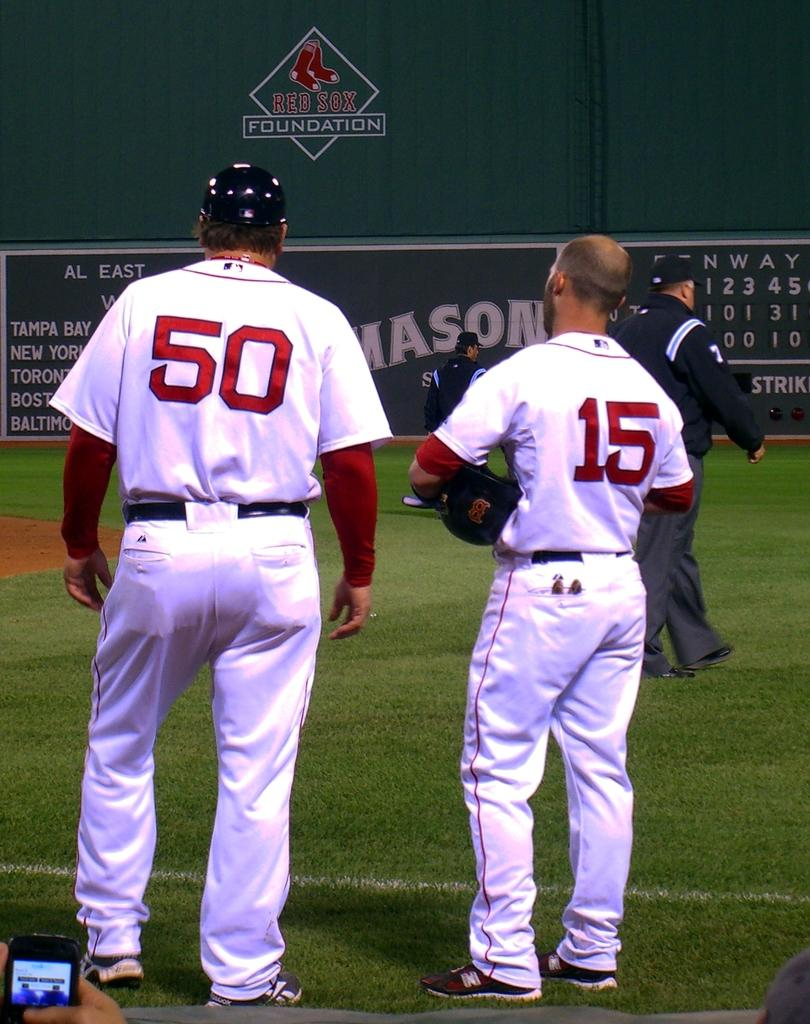<image>
Share a concise interpretation of the image provided. Baseball players on the field wearing 50 and 15 jerseys. 